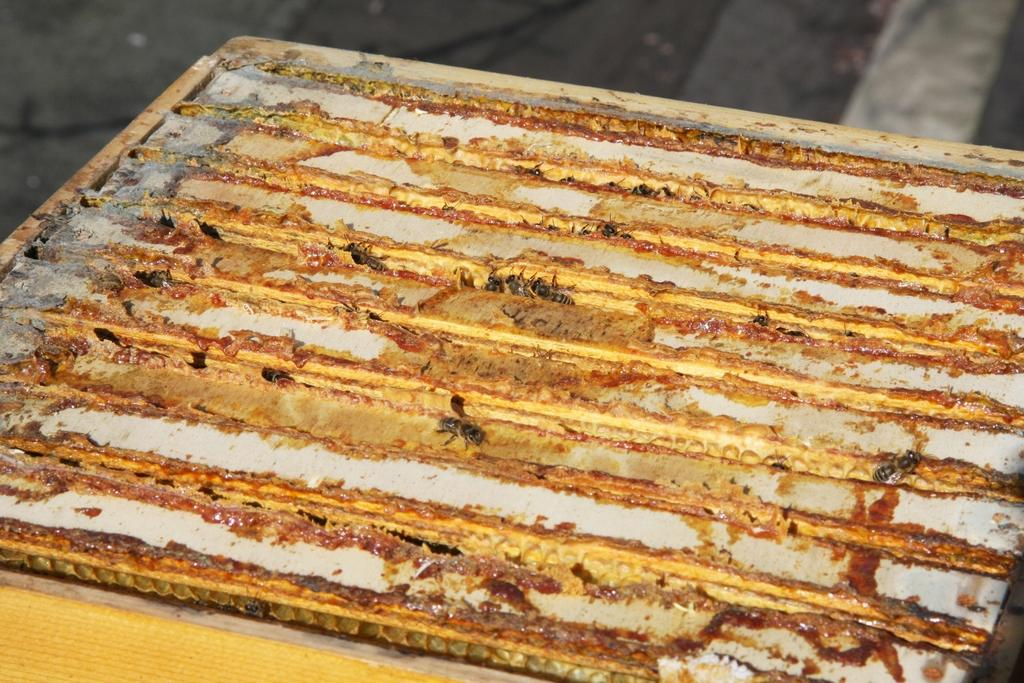What insects can be seen in the image? There are bees on a board in the image. What part of the image is visible at the top? The floor is visible at the top of the image. What time of day is it in the image, and how does the morning light affect the bees? The time of day is not mentioned in the image, and there is no indication of morning light or its effect on the bees. How does the tramp interact with the bees in the image? There is no tramp present in the image, so it is not possible to determine how a tramp might interact with the bees. 